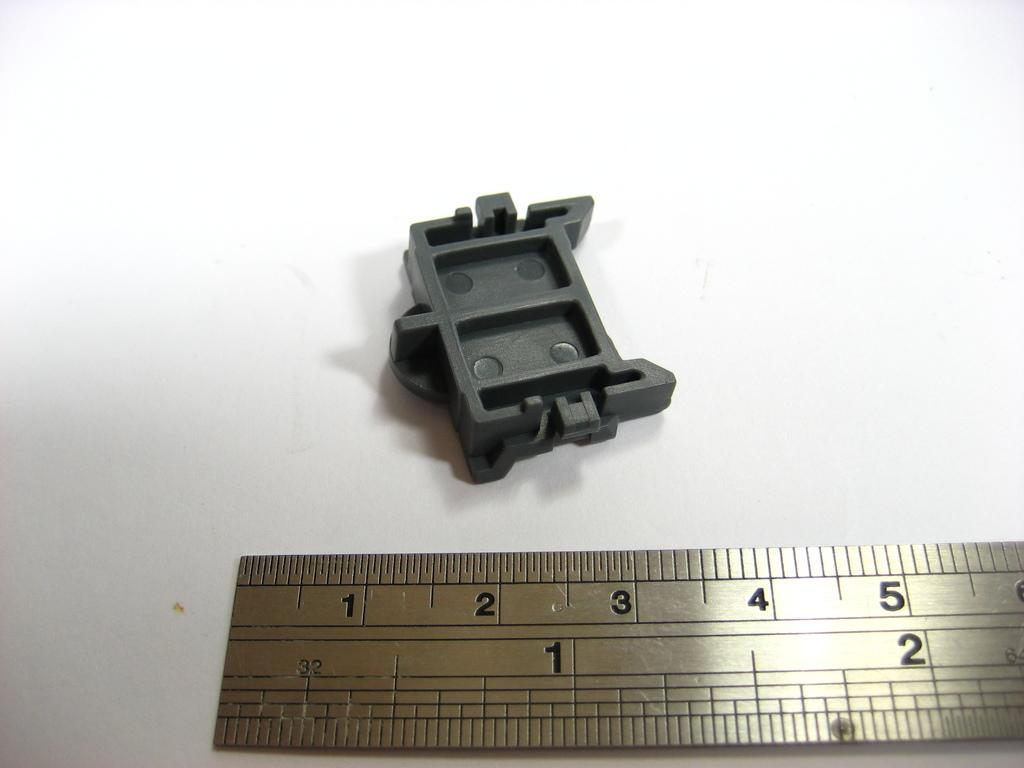<image>
Share a concise interpretation of the image provided. A ruler showing numbers 1 to 5 and a grey plastic part laying on a white table. 